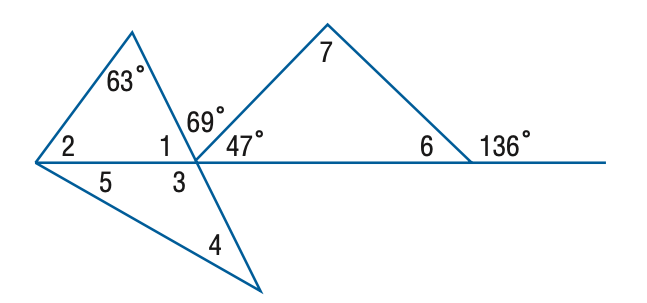Answer the mathemtical geometry problem and directly provide the correct option letter.
Question: Find the measure of \angle 1 if m \angle 4 = m \angle 5.
Choices: A: 53 B: 63 C: 64 D: 69 C 